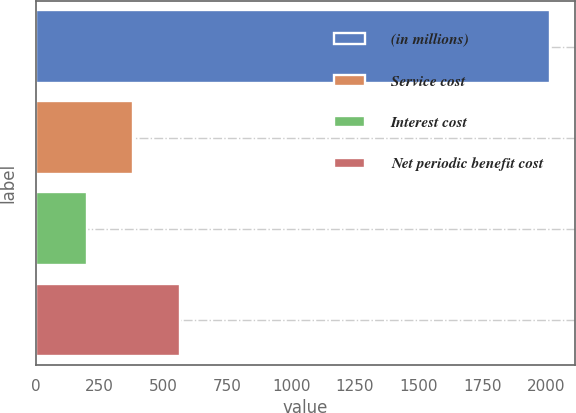Convert chart. <chart><loc_0><loc_0><loc_500><loc_500><bar_chart><fcel>(in millions)<fcel>Service cost<fcel>Interest cost<fcel>Net periodic benefit cost<nl><fcel>2013<fcel>382.2<fcel>201<fcel>563.4<nl></chart> 